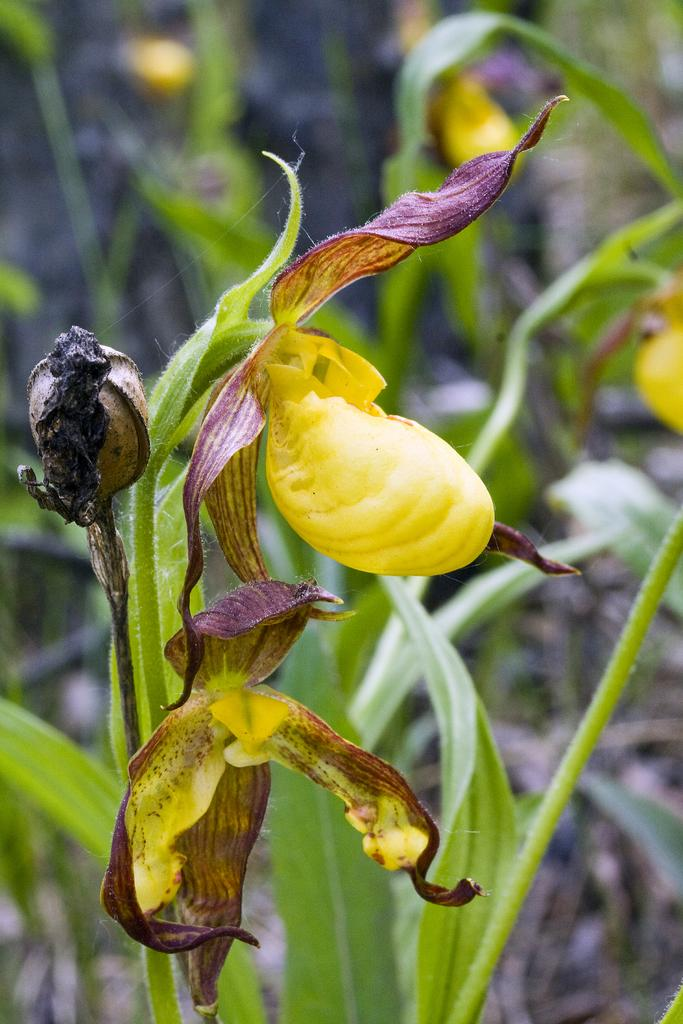Where was the image taken? The image was taken outdoors. What can be seen in the background of the image? There are plants in the background of the image. What is the main subject of the image? The main subject of the image is a plant with a bud. How many flowers are on the plant? The plant has two yellow flowers. Who is the friend standing next to the plant in the image? There is no friend present in the image; it only features a plant with a bud and two yellow flowers. 